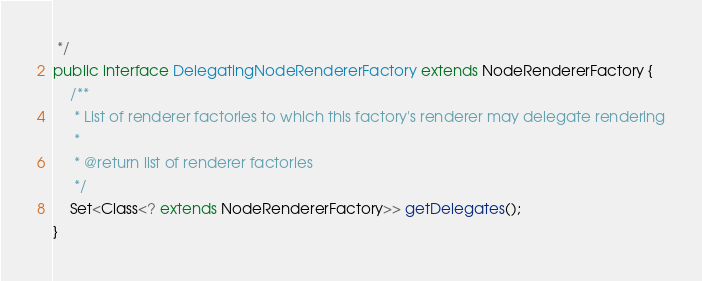<code> <loc_0><loc_0><loc_500><loc_500><_Java_> */
public interface DelegatingNodeRendererFactory extends NodeRendererFactory {
    /**
     * List of renderer factories to which this factory's renderer may delegate rendering
     *
     * @return list of renderer factories
     */
    Set<Class<? extends NodeRendererFactory>> getDelegates();
}
</code> 